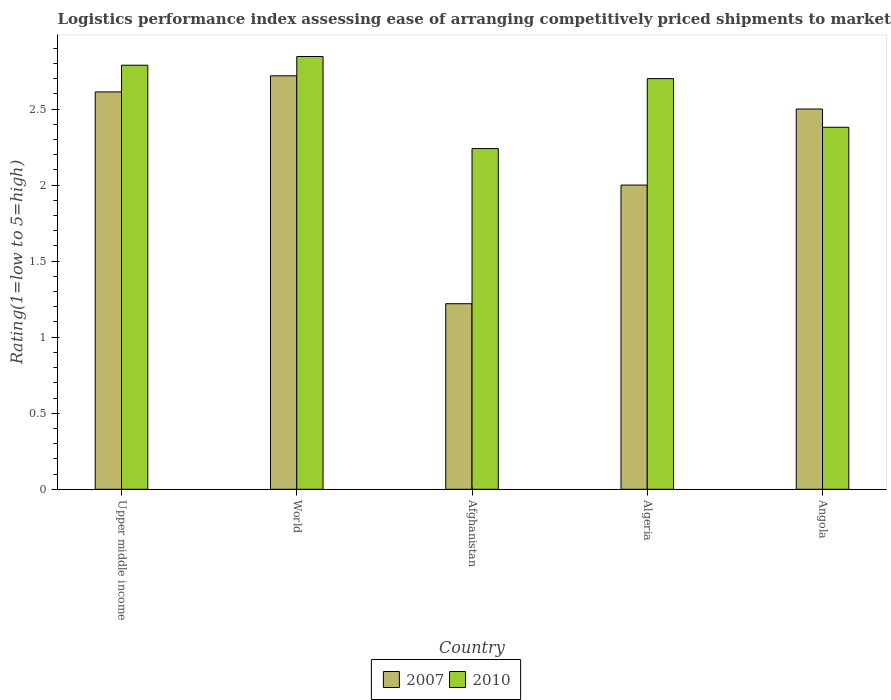Are the number of bars on each tick of the X-axis equal?
Make the answer very short. Yes. How many bars are there on the 1st tick from the right?
Your answer should be compact. 2. What is the label of the 2nd group of bars from the left?
Provide a succinct answer. World. In how many cases, is the number of bars for a given country not equal to the number of legend labels?
Offer a very short reply. 0. Across all countries, what is the maximum Logistic performance index in 2007?
Your answer should be compact. 2.72. Across all countries, what is the minimum Logistic performance index in 2010?
Provide a succinct answer. 2.24. In which country was the Logistic performance index in 2007 maximum?
Give a very brief answer. World. In which country was the Logistic performance index in 2007 minimum?
Make the answer very short. Afghanistan. What is the total Logistic performance index in 2007 in the graph?
Keep it short and to the point. 11.05. What is the difference between the Logistic performance index in 2010 in Angola and that in Upper middle income?
Your answer should be very brief. -0.41. What is the difference between the Logistic performance index in 2010 in Afghanistan and the Logistic performance index in 2007 in World?
Give a very brief answer. -0.48. What is the average Logistic performance index in 2010 per country?
Make the answer very short. 2.59. What is the difference between the Logistic performance index of/in 2007 and Logistic performance index of/in 2010 in Upper middle income?
Ensure brevity in your answer.  -0.18. In how many countries, is the Logistic performance index in 2007 greater than 0.5?
Provide a short and direct response. 5. What is the ratio of the Logistic performance index in 2010 in Algeria to that in Upper middle income?
Make the answer very short. 0.97. Is the Logistic performance index in 2010 in Angola less than that in Upper middle income?
Provide a short and direct response. Yes. Is the difference between the Logistic performance index in 2007 in Algeria and World greater than the difference between the Logistic performance index in 2010 in Algeria and World?
Your answer should be very brief. No. What is the difference between the highest and the second highest Logistic performance index in 2010?
Make the answer very short. 0.06. What is the difference between the highest and the lowest Logistic performance index in 2010?
Your response must be concise. 0.61. What does the 1st bar from the left in Angola represents?
Offer a very short reply. 2007. What is the difference between two consecutive major ticks on the Y-axis?
Your response must be concise. 0.5. How many legend labels are there?
Your response must be concise. 2. What is the title of the graph?
Provide a succinct answer. Logistics performance index assessing ease of arranging competitively priced shipments to markets. What is the label or title of the Y-axis?
Offer a terse response. Rating(1=low to 5=high). What is the Rating(1=low to 5=high) in 2007 in Upper middle income?
Offer a very short reply. 2.61. What is the Rating(1=low to 5=high) in 2010 in Upper middle income?
Keep it short and to the point. 2.79. What is the Rating(1=low to 5=high) of 2007 in World?
Keep it short and to the point. 2.72. What is the Rating(1=low to 5=high) in 2010 in World?
Keep it short and to the point. 2.85. What is the Rating(1=low to 5=high) of 2007 in Afghanistan?
Your answer should be compact. 1.22. What is the Rating(1=low to 5=high) in 2010 in Afghanistan?
Provide a short and direct response. 2.24. What is the Rating(1=low to 5=high) in 2007 in Algeria?
Make the answer very short. 2. What is the Rating(1=low to 5=high) of 2010 in Angola?
Your answer should be very brief. 2.38. Across all countries, what is the maximum Rating(1=low to 5=high) in 2007?
Make the answer very short. 2.72. Across all countries, what is the maximum Rating(1=low to 5=high) in 2010?
Make the answer very short. 2.85. Across all countries, what is the minimum Rating(1=low to 5=high) of 2007?
Your response must be concise. 1.22. Across all countries, what is the minimum Rating(1=low to 5=high) of 2010?
Keep it short and to the point. 2.24. What is the total Rating(1=low to 5=high) of 2007 in the graph?
Provide a short and direct response. 11.05. What is the total Rating(1=low to 5=high) of 2010 in the graph?
Your answer should be compact. 12.95. What is the difference between the Rating(1=low to 5=high) in 2007 in Upper middle income and that in World?
Provide a short and direct response. -0.11. What is the difference between the Rating(1=low to 5=high) in 2010 in Upper middle income and that in World?
Provide a short and direct response. -0.06. What is the difference between the Rating(1=low to 5=high) in 2007 in Upper middle income and that in Afghanistan?
Offer a terse response. 1.39. What is the difference between the Rating(1=low to 5=high) in 2010 in Upper middle income and that in Afghanistan?
Your answer should be compact. 0.55. What is the difference between the Rating(1=low to 5=high) of 2007 in Upper middle income and that in Algeria?
Your response must be concise. 0.61. What is the difference between the Rating(1=low to 5=high) of 2010 in Upper middle income and that in Algeria?
Offer a very short reply. 0.09. What is the difference between the Rating(1=low to 5=high) of 2007 in Upper middle income and that in Angola?
Provide a succinct answer. 0.11. What is the difference between the Rating(1=low to 5=high) of 2010 in Upper middle income and that in Angola?
Offer a terse response. 0.41. What is the difference between the Rating(1=low to 5=high) in 2007 in World and that in Afghanistan?
Provide a succinct answer. 1.5. What is the difference between the Rating(1=low to 5=high) of 2010 in World and that in Afghanistan?
Your response must be concise. 0.61. What is the difference between the Rating(1=low to 5=high) of 2007 in World and that in Algeria?
Offer a terse response. 0.72. What is the difference between the Rating(1=low to 5=high) in 2010 in World and that in Algeria?
Provide a succinct answer. 0.15. What is the difference between the Rating(1=low to 5=high) of 2007 in World and that in Angola?
Give a very brief answer. 0.22. What is the difference between the Rating(1=low to 5=high) of 2010 in World and that in Angola?
Ensure brevity in your answer.  0.47. What is the difference between the Rating(1=low to 5=high) in 2007 in Afghanistan and that in Algeria?
Offer a very short reply. -0.78. What is the difference between the Rating(1=low to 5=high) in 2010 in Afghanistan and that in Algeria?
Provide a short and direct response. -0.46. What is the difference between the Rating(1=low to 5=high) of 2007 in Afghanistan and that in Angola?
Provide a short and direct response. -1.28. What is the difference between the Rating(1=low to 5=high) of 2010 in Afghanistan and that in Angola?
Offer a terse response. -0.14. What is the difference between the Rating(1=low to 5=high) in 2007 in Algeria and that in Angola?
Your response must be concise. -0.5. What is the difference between the Rating(1=low to 5=high) in 2010 in Algeria and that in Angola?
Ensure brevity in your answer.  0.32. What is the difference between the Rating(1=low to 5=high) in 2007 in Upper middle income and the Rating(1=low to 5=high) in 2010 in World?
Provide a short and direct response. -0.23. What is the difference between the Rating(1=low to 5=high) of 2007 in Upper middle income and the Rating(1=low to 5=high) of 2010 in Afghanistan?
Offer a terse response. 0.37. What is the difference between the Rating(1=low to 5=high) in 2007 in Upper middle income and the Rating(1=low to 5=high) in 2010 in Algeria?
Make the answer very short. -0.09. What is the difference between the Rating(1=low to 5=high) of 2007 in Upper middle income and the Rating(1=low to 5=high) of 2010 in Angola?
Your answer should be compact. 0.23. What is the difference between the Rating(1=low to 5=high) of 2007 in World and the Rating(1=low to 5=high) of 2010 in Afghanistan?
Your answer should be very brief. 0.48. What is the difference between the Rating(1=low to 5=high) in 2007 in World and the Rating(1=low to 5=high) in 2010 in Algeria?
Your answer should be compact. 0.02. What is the difference between the Rating(1=low to 5=high) of 2007 in World and the Rating(1=low to 5=high) of 2010 in Angola?
Your answer should be very brief. 0.34. What is the difference between the Rating(1=low to 5=high) of 2007 in Afghanistan and the Rating(1=low to 5=high) of 2010 in Algeria?
Give a very brief answer. -1.48. What is the difference between the Rating(1=low to 5=high) in 2007 in Afghanistan and the Rating(1=low to 5=high) in 2010 in Angola?
Your answer should be very brief. -1.16. What is the difference between the Rating(1=low to 5=high) of 2007 in Algeria and the Rating(1=low to 5=high) of 2010 in Angola?
Keep it short and to the point. -0.38. What is the average Rating(1=low to 5=high) of 2007 per country?
Ensure brevity in your answer.  2.21. What is the average Rating(1=low to 5=high) in 2010 per country?
Your answer should be compact. 2.59. What is the difference between the Rating(1=low to 5=high) in 2007 and Rating(1=low to 5=high) in 2010 in Upper middle income?
Keep it short and to the point. -0.18. What is the difference between the Rating(1=low to 5=high) in 2007 and Rating(1=low to 5=high) in 2010 in World?
Provide a short and direct response. -0.13. What is the difference between the Rating(1=low to 5=high) of 2007 and Rating(1=low to 5=high) of 2010 in Afghanistan?
Your answer should be very brief. -1.02. What is the difference between the Rating(1=low to 5=high) in 2007 and Rating(1=low to 5=high) in 2010 in Angola?
Your response must be concise. 0.12. What is the ratio of the Rating(1=low to 5=high) in 2007 in Upper middle income to that in World?
Ensure brevity in your answer.  0.96. What is the ratio of the Rating(1=low to 5=high) in 2010 in Upper middle income to that in World?
Ensure brevity in your answer.  0.98. What is the ratio of the Rating(1=low to 5=high) in 2007 in Upper middle income to that in Afghanistan?
Make the answer very short. 2.14. What is the ratio of the Rating(1=low to 5=high) of 2010 in Upper middle income to that in Afghanistan?
Provide a succinct answer. 1.24. What is the ratio of the Rating(1=low to 5=high) of 2007 in Upper middle income to that in Algeria?
Give a very brief answer. 1.31. What is the ratio of the Rating(1=low to 5=high) of 2010 in Upper middle income to that in Algeria?
Provide a succinct answer. 1.03. What is the ratio of the Rating(1=low to 5=high) in 2007 in Upper middle income to that in Angola?
Give a very brief answer. 1.04. What is the ratio of the Rating(1=low to 5=high) of 2010 in Upper middle income to that in Angola?
Your answer should be compact. 1.17. What is the ratio of the Rating(1=low to 5=high) in 2007 in World to that in Afghanistan?
Your response must be concise. 2.23. What is the ratio of the Rating(1=low to 5=high) of 2010 in World to that in Afghanistan?
Offer a very short reply. 1.27. What is the ratio of the Rating(1=low to 5=high) of 2007 in World to that in Algeria?
Offer a terse response. 1.36. What is the ratio of the Rating(1=low to 5=high) in 2010 in World to that in Algeria?
Your response must be concise. 1.05. What is the ratio of the Rating(1=low to 5=high) of 2007 in World to that in Angola?
Provide a short and direct response. 1.09. What is the ratio of the Rating(1=low to 5=high) of 2010 in World to that in Angola?
Provide a succinct answer. 1.2. What is the ratio of the Rating(1=low to 5=high) of 2007 in Afghanistan to that in Algeria?
Offer a very short reply. 0.61. What is the ratio of the Rating(1=low to 5=high) of 2010 in Afghanistan to that in Algeria?
Provide a succinct answer. 0.83. What is the ratio of the Rating(1=low to 5=high) in 2007 in Afghanistan to that in Angola?
Keep it short and to the point. 0.49. What is the ratio of the Rating(1=low to 5=high) in 2010 in Afghanistan to that in Angola?
Provide a succinct answer. 0.94. What is the ratio of the Rating(1=low to 5=high) in 2007 in Algeria to that in Angola?
Make the answer very short. 0.8. What is the ratio of the Rating(1=low to 5=high) of 2010 in Algeria to that in Angola?
Your answer should be compact. 1.13. What is the difference between the highest and the second highest Rating(1=low to 5=high) of 2007?
Offer a very short reply. 0.11. What is the difference between the highest and the second highest Rating(1=low to 5=high) of 2010?
Make the answer very short. 0.06. What is the difference between the highest and the lowest Rating(1=low to 5=high) of 2007?
Your answer should be very brief. 1.5. What is the difference between the highest and the lowest Rating(1=low to 5=high) of 2010?
Your answer should be compact. 0.61. 